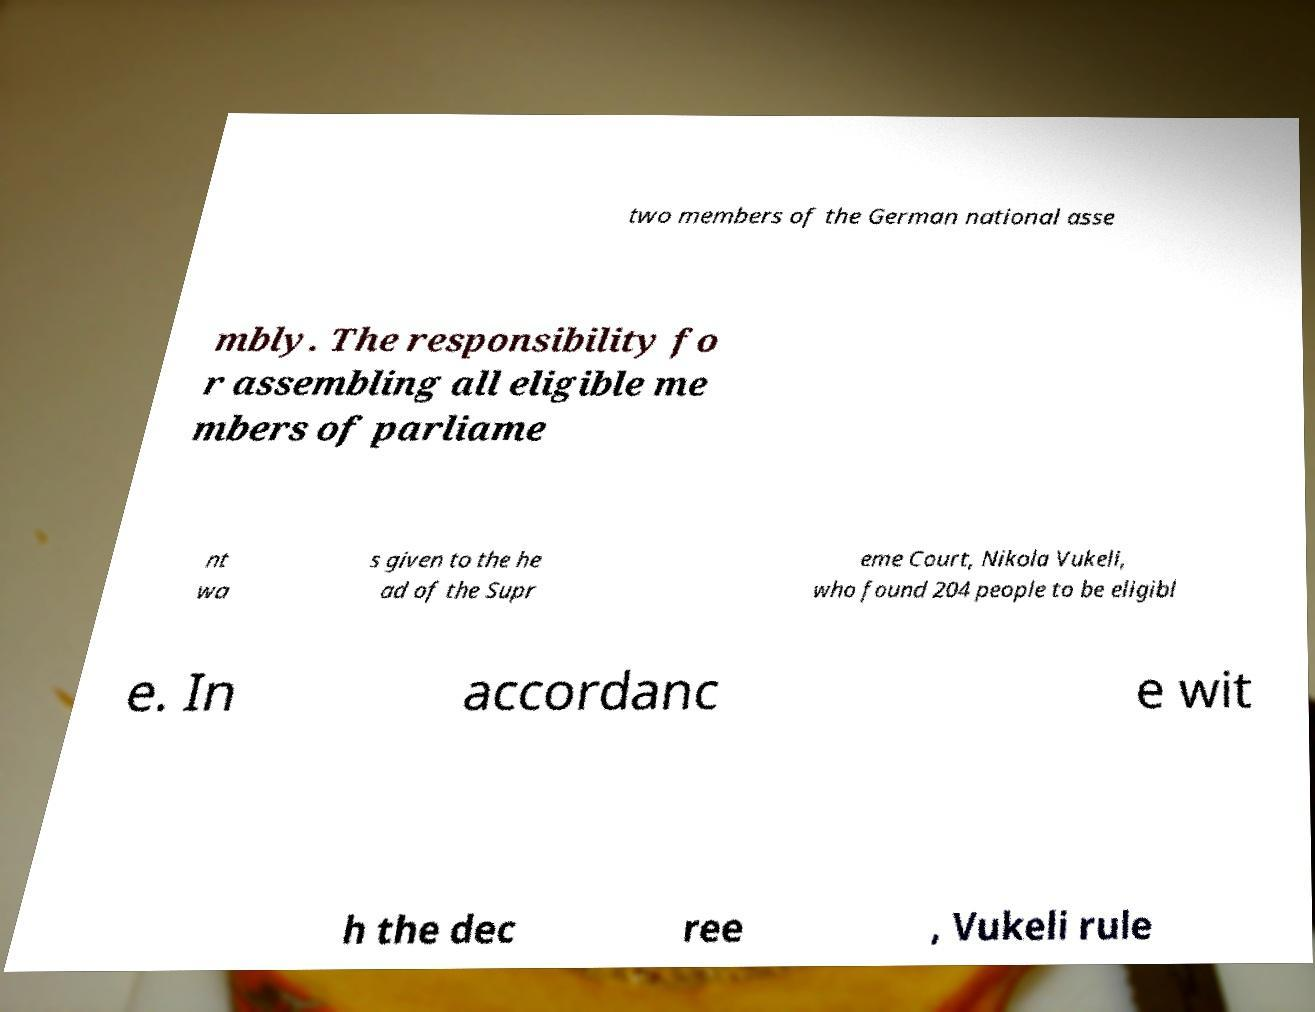Could you extract and type out the text from this image? two members of the German national asse mbly. The responsibility fo r assembling all eligible me mbers of parliame nt wa s given to the he ad of the Supr eme Court, Nikola Vukeli, who found 204 people to be eligibl e. In accordanc e wit h the dec ree , Vukeli rule 